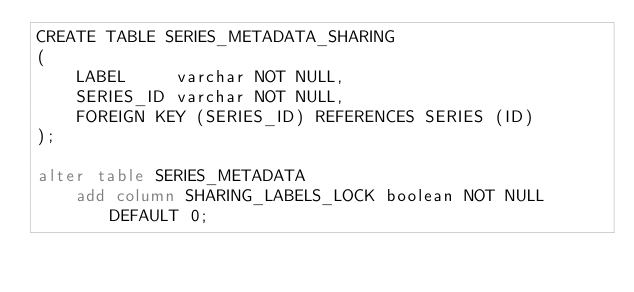<code> <loc_0><loc_0><loc_500><loc_500><_SQL_>CREATE TABLE SERIES_METADATA_SHARING
(
    LABEL     varchar NOT NULL,
    SERIES_ID varchar NOT NULL,
    FOREIGN KEY (SERIES_ID) REFERENCES SERIES (ID)
);

alter table SERIES_METADATA
    add column SHARING_LABELS_LOCK boolean NOT NULL DEFAULT 0;
</code> 